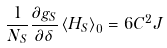<formula> <loc_0><loc_0><loc_500><loc_500>\frac { 1 } { N _ { S } } \frac { \partial g _ { S } } { \partial \delta } \left \langle H _ { S } \right \rangle _ { 0 } = 6 C ^ { 2 } J</formula> 